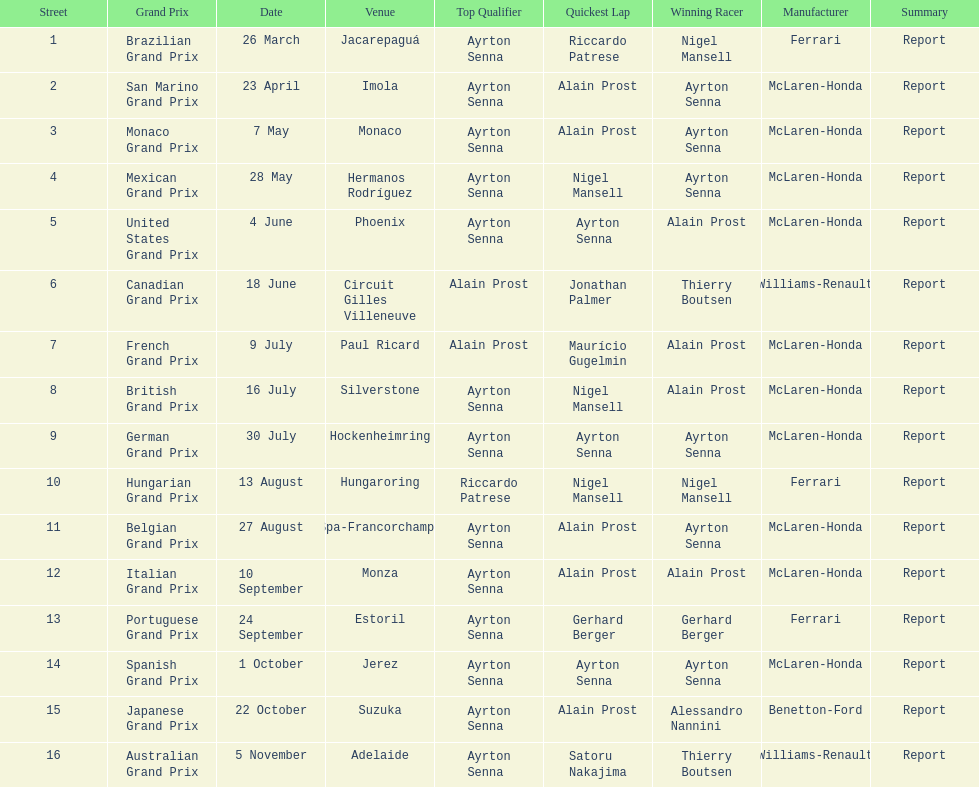How many races occurred before alain prost won a pole position? 5. 